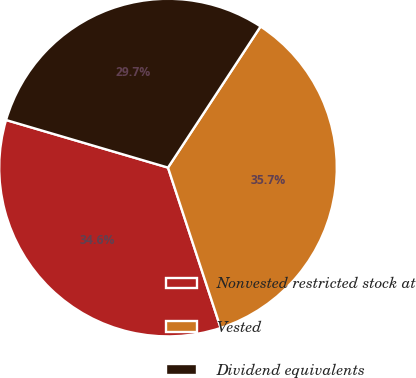Convert chart. <chart><loc_0><loc_0><loc_500><loc_500><pie_chart><fcel>Nonvested restricted stock at<fcel>Vested<fcel>Dividend equivalents<nl><fcel>34.6%<fcel>35.71%<fcel>29.69%<nl></chart> 